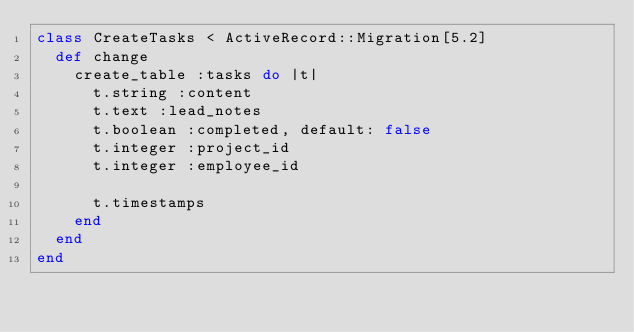Convert code to text. <code><loc_0><loc_0><loc_500><loc_500><_Ruby_>class CreateTasks < ActiveRecord::Migration[5.2]
  def change
    create_table :tasks do |t|
      t.string :content
      t.text :lead_notes
      t.boolean :completed, default: false
      t.integer :project_id
      t.integer :employee_id

      t.timestamps
    end
  end
end
</code> 